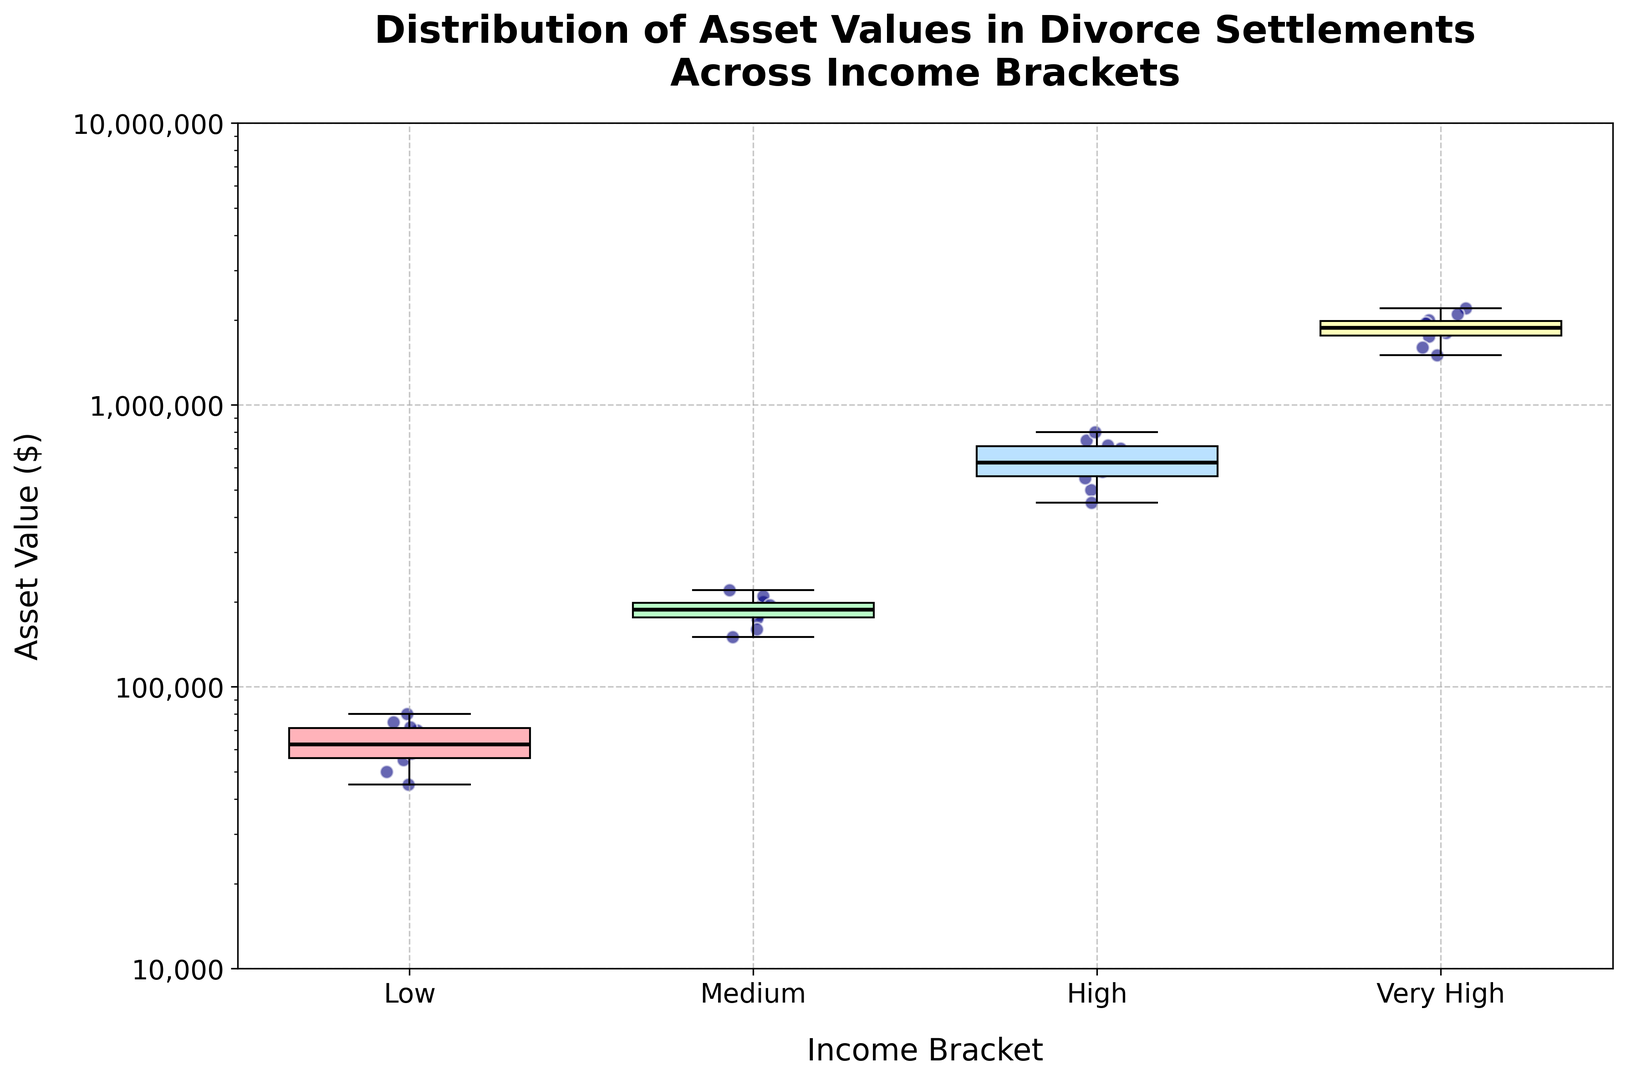What's the median asset value in the 'Medium' income bracket? Identify the 'Medium' income bracket from the four shown, and note the horizontal line within the associated box, which represents the median asset value.
Answer: 190000 How does the interquartile range (IQR) of the 'High' income bracket compare to the 'Low' income bracket? Find the lengths of the boxes for both the 'High' and 'Low' income brackets, which represent their IQRs, then determine which box is longer.
Answer: The 'High' IQR is larger than the 'Low' IQR Which income bracket shows the most variability in asset values? Observe the overall spread of the boxes and the whiskers for all income brackets. The bracket with the longest whiskers/box indicates the most variability.
Answer: Very High What is the range of asset values in the 'Low' income bracket? Identify the top and bottom whiskers for the 'Low' income bracket. The range is the difference between the highest and lowest values indicated by these whiskers.
Answer: 45000 to 80000 Which income bracket has the highest median asset value? Look at the horizontal lines (medians) within each box plot to determine which one is at the highest position on the y-axis.
Answer: Very High What is the difference in the median asset value between the 'Low' and 'High' income brackets? Determine the median values for the 'Low' and 'High' brackets from their respective box plots, and then calculate the difference between these values.
Answer: 650000 - 70000 = 580000 Are there any outliers in the 'Low' income bracket? Check for any points that are clearly separated from the whiskers of the 'Low' income bracket's box plot, as these represent outliers.
Answer: No How does the 75th percentile asset value in the 'Medium' bracket compare to the median asset value in the 'High' bracket? Identify the upper edge of the box in the 'Medium' bracket for the 75th percentile, and the horizontal median line for the 'High' bracket, then compare these values.
Answer: The 75th percentile in 'Medium' is less than the median in 'High' Which income bracket has the smallest interquartile range (IQR)? Compare the lengths of the boxes (IQRs) across all income brackets to find the shortest one.
Answer: Low 